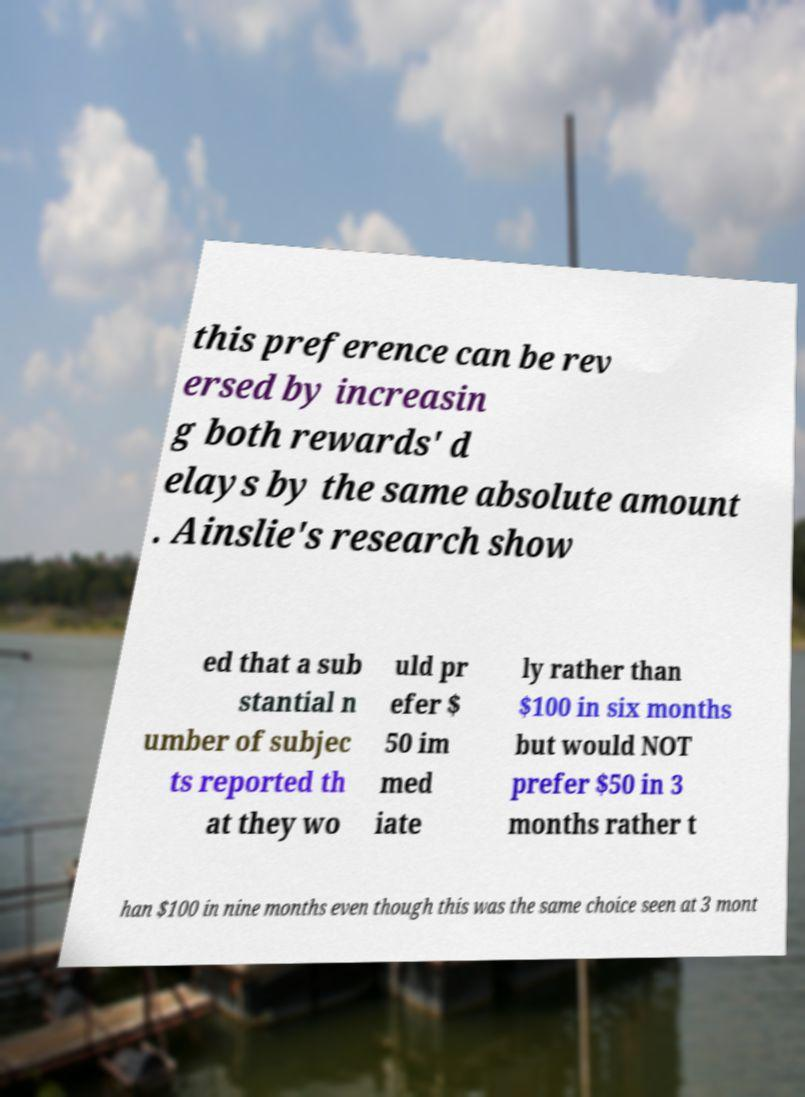Please read and relay the text visible in this image. What does it say? this preference can be rev ersed by increasin g both rewards' d elays by the same absolute amount . Ainslie's research show ed that a sub stantial n umber of subjec ts reported th at they wo uld pr efer $ 50 im med iate ly rather than $100 in six months but would NOT prefer $50 in 3 months rather t han $100 in nine months even though this was the same choice seen at 3 mont 